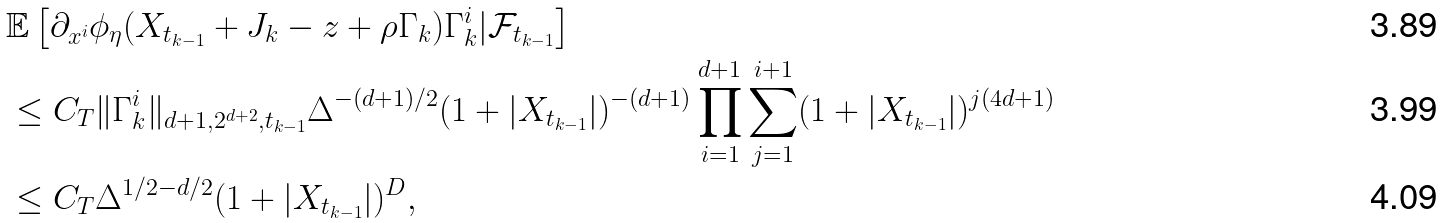<formula> <loc_0><loc_0><loc_500><loc_500>& \mathbb { E } \left [ \partial _ { x ^ { i } } \phi _ { \eta } ( X _ { t _ { k - 1 } } + J _ { k } - z + \rho \Gamma _ { k } ) \Gamma ^ { i } _ { k } | { \mathcal { F } } _ { t _ { k - 1 } } \right ] \\ & \leq C _ { T } \| \Gamma _ { k } ^ { i } \| _ { d + 1 , 2 ^ { d + 2 } , t _ { k - 1 } } \Delta ^ { - ( d + 1 ) / 2 } ( 1 + | X _ { t _ { k - 1 } } | ) ^ { - ( d + 1 ) } \prod _ { i = 1 } ^ { d + 1 } \sum _ { j = 1 } ^ { i + 1 } ( 1 + | X _ { t _ { k - 1 } } | ) ^ { j ( 4 d + 1 ) } \\ & \leq C _ { T } \Delta ^ { 1 / 2 - d / 2 } ( 1 + | X _ { t _ { k - 1 } } | ) ^ { D } ,</formula> 